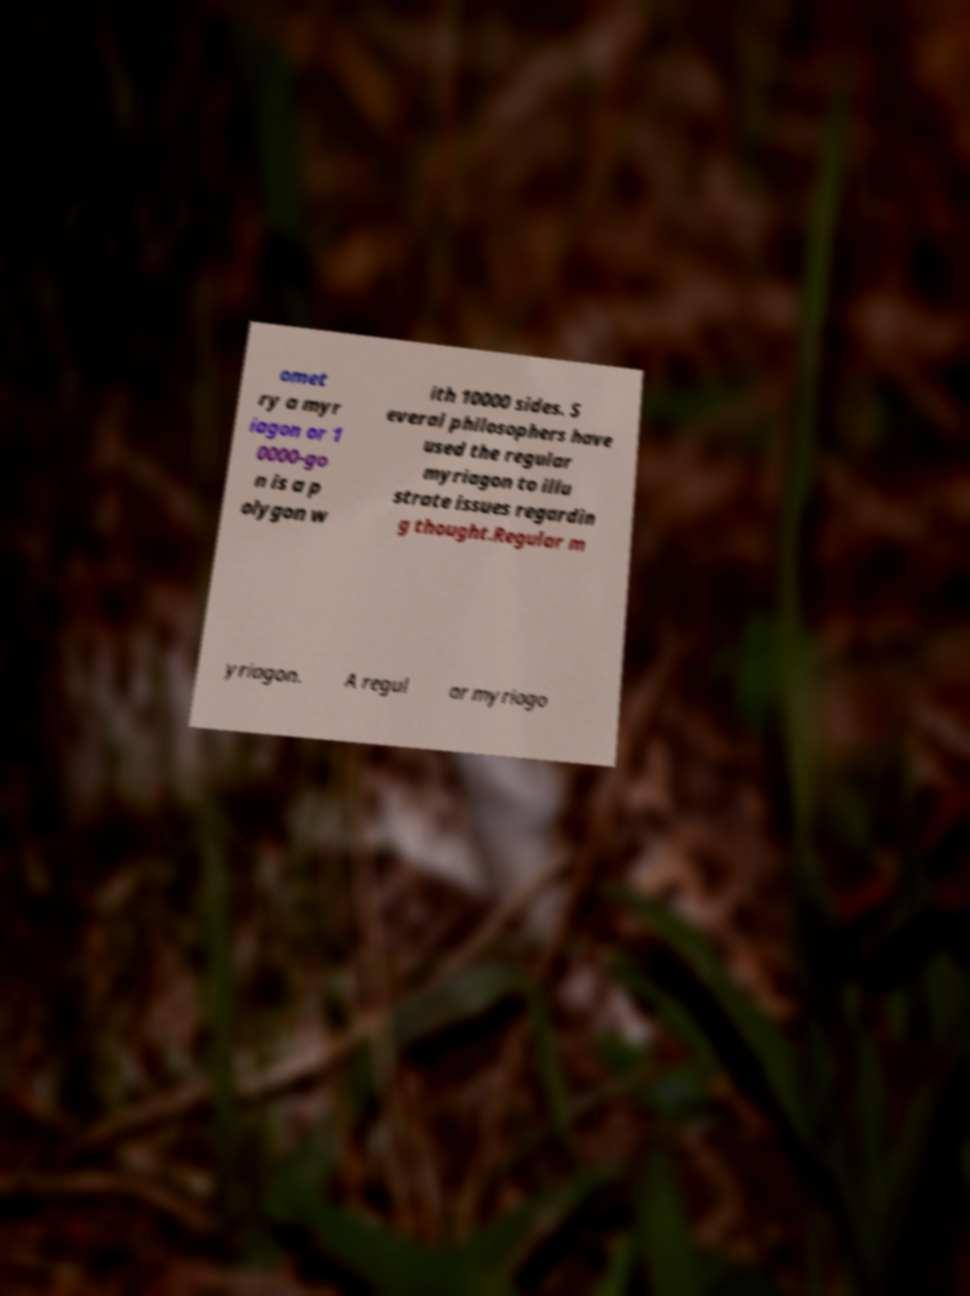Can you read and provide the text displayed in the image?This photo seems to have some interesting text. Can you extract and type it out for me? omet ry a myr iagon or 1 0000-go n is a p olygon w ith 10000 sides. S everal philosophers have used the regular myriagon to illu strate issues regardin g thought.Regular m yriagon. A regul ar myriago 